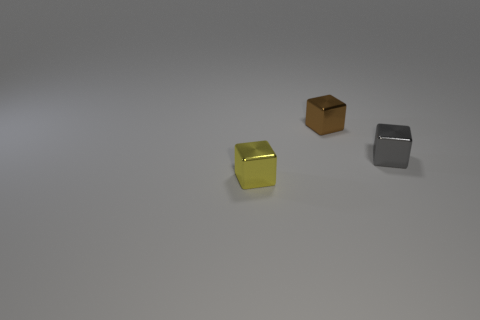There is a small shiny thing left of the small cube behind the tiny thing that is to the right of the brown metallic cube; what is its color?
Your answer should be compact. Yellow. Are there an equal number of tiny shiny things behind the small yellow cube and red matte cubes?
Your response must be concise. No. Is there any other thing that is the same material as the yellow object?
Make the answer very short. Yes. There is a small block in front of the metallic block that is on the right side of the brown metal block; is there a small yellow cube that is right of it?
Provide a short and direct response. No. Are there fewer tiny yellow blocks that are on the left side of the small yellow shiny object than large red rubber objects?
Offer a very short reply. No. How many other things are there of the same shape as the tiny brown shiny object?
Your response must be concise. 2. What number of objects are blocks on the right side of the small brown thing or small things on the left side of the gray thing?
Provide a short and direct response. 3. There is a block that is behind the yellow thing and in front of the brown cube; what is its size?
Provide a short and direct response. Small. Do the tiny metallic thing behind the gray shiny object and the tiny gray metallic thing have the same shape?
Your answer should be compact. Yes. What is the size of the brown cube that is behind the metallic cube on the right side of the thing behind the tiny gray object?
Ensure brevity in your answer.  Small. 